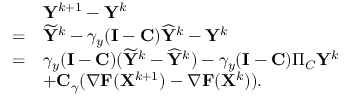<formula> <loc_0><loc_0><loc_500><loc_500>\begin{array} { r l } & { { Y } ^ { k + 1 } - { Y } ^ { k } } \\ { = } & { \widetilde { Y } ^ { k } - \gamma _ { y } ( { I } - { C } ) \widehat { Y } ^ { k } - { Y } ^ { k } } \\ { = } & { \gamma _ { y } ( { I } - { C } ) ( \widetilde { Y } ^ { k } - \widehat { Y } ^ { k } ) - \gamma _ { y } ( { I } - { C } ) \Pi _ { C } { Y } ^ { k } } \\ & { + { C } _ { \gamma } ( \nabla { F } ( { X } ^ { k + 1 } ) - \nabla { F } ( { X } ^ { k } ) ) . } \end{array}</formula> 